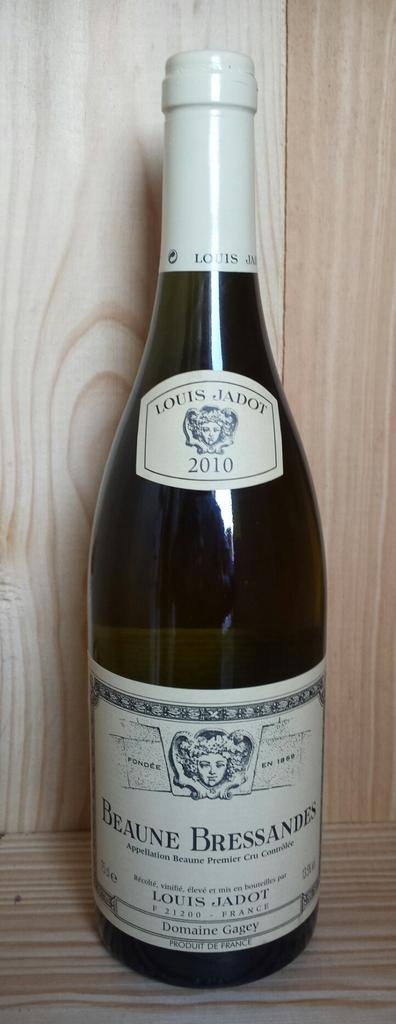<image>
Render a clear and concise summary of the photo. A bottle of wine called Louis Jadot 2010 sits on a self. 